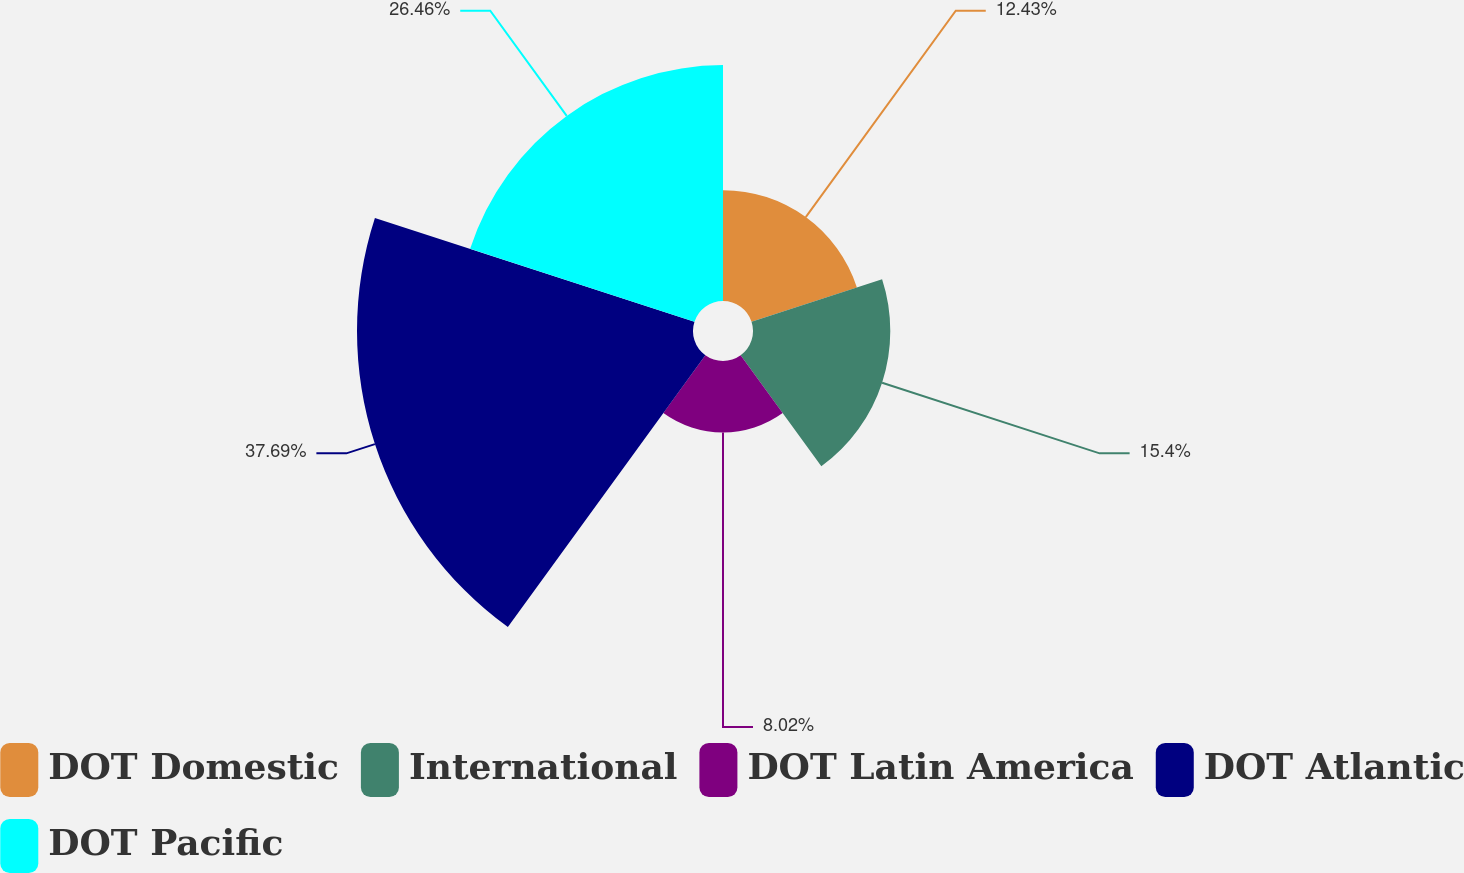Convert chart to OTSL. <chart><loc_0><loc_0><loc_500><loc_500><pie_chart><fcel>DOT Domestic<fcel>International<fcel>DOT Latin America<fcel>DOT Atlantic<fcel>DOT Pacific<nl><fcel>12.43%<fcel>15.4%<fcel>8.02%<fcel>37.69%<fcel>26.46%<nl></chart> 